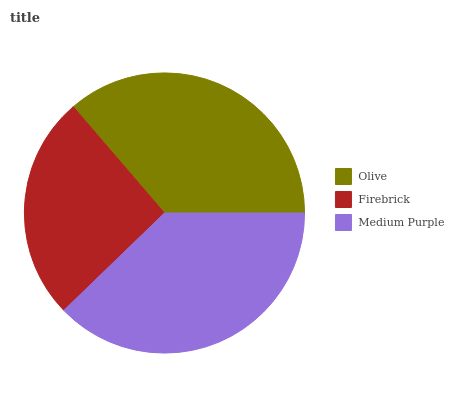Is Firebrick the minimum?
Answer yes or no. Yes. Is Medium Purple the maximum?
Answer yes or no. Yes. Is Medium Purple the minimum?
Answer yes or no. No. Is Firebrick the maximum?
Answer yes or no. No. Is Medium Purple greater than Firebrick?
Answer yes or no. Yes. Is Firebrick less than Medium Purple?
Answer yes or no. Yes. Is Firebrick greater than Medium Purple?
Answer yes or no. No. Is Medium Purple less than Firebrick?
Answer yes or no. No. Is Olive the high median?
Answer yes or no. Yes. Is Olive the low median?
Answer yes or no. Yes. Is Firebrick the high median?
Answer yes or no. No. Is Firebrick the low median?
Answer yes or no. No. 